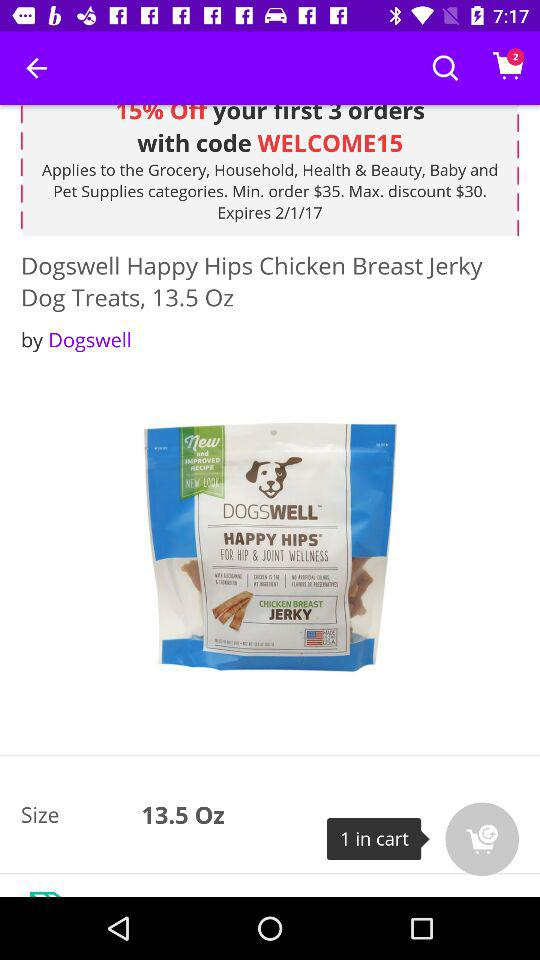What is the code expiration date? The code expiration date is February 1, 2017. 